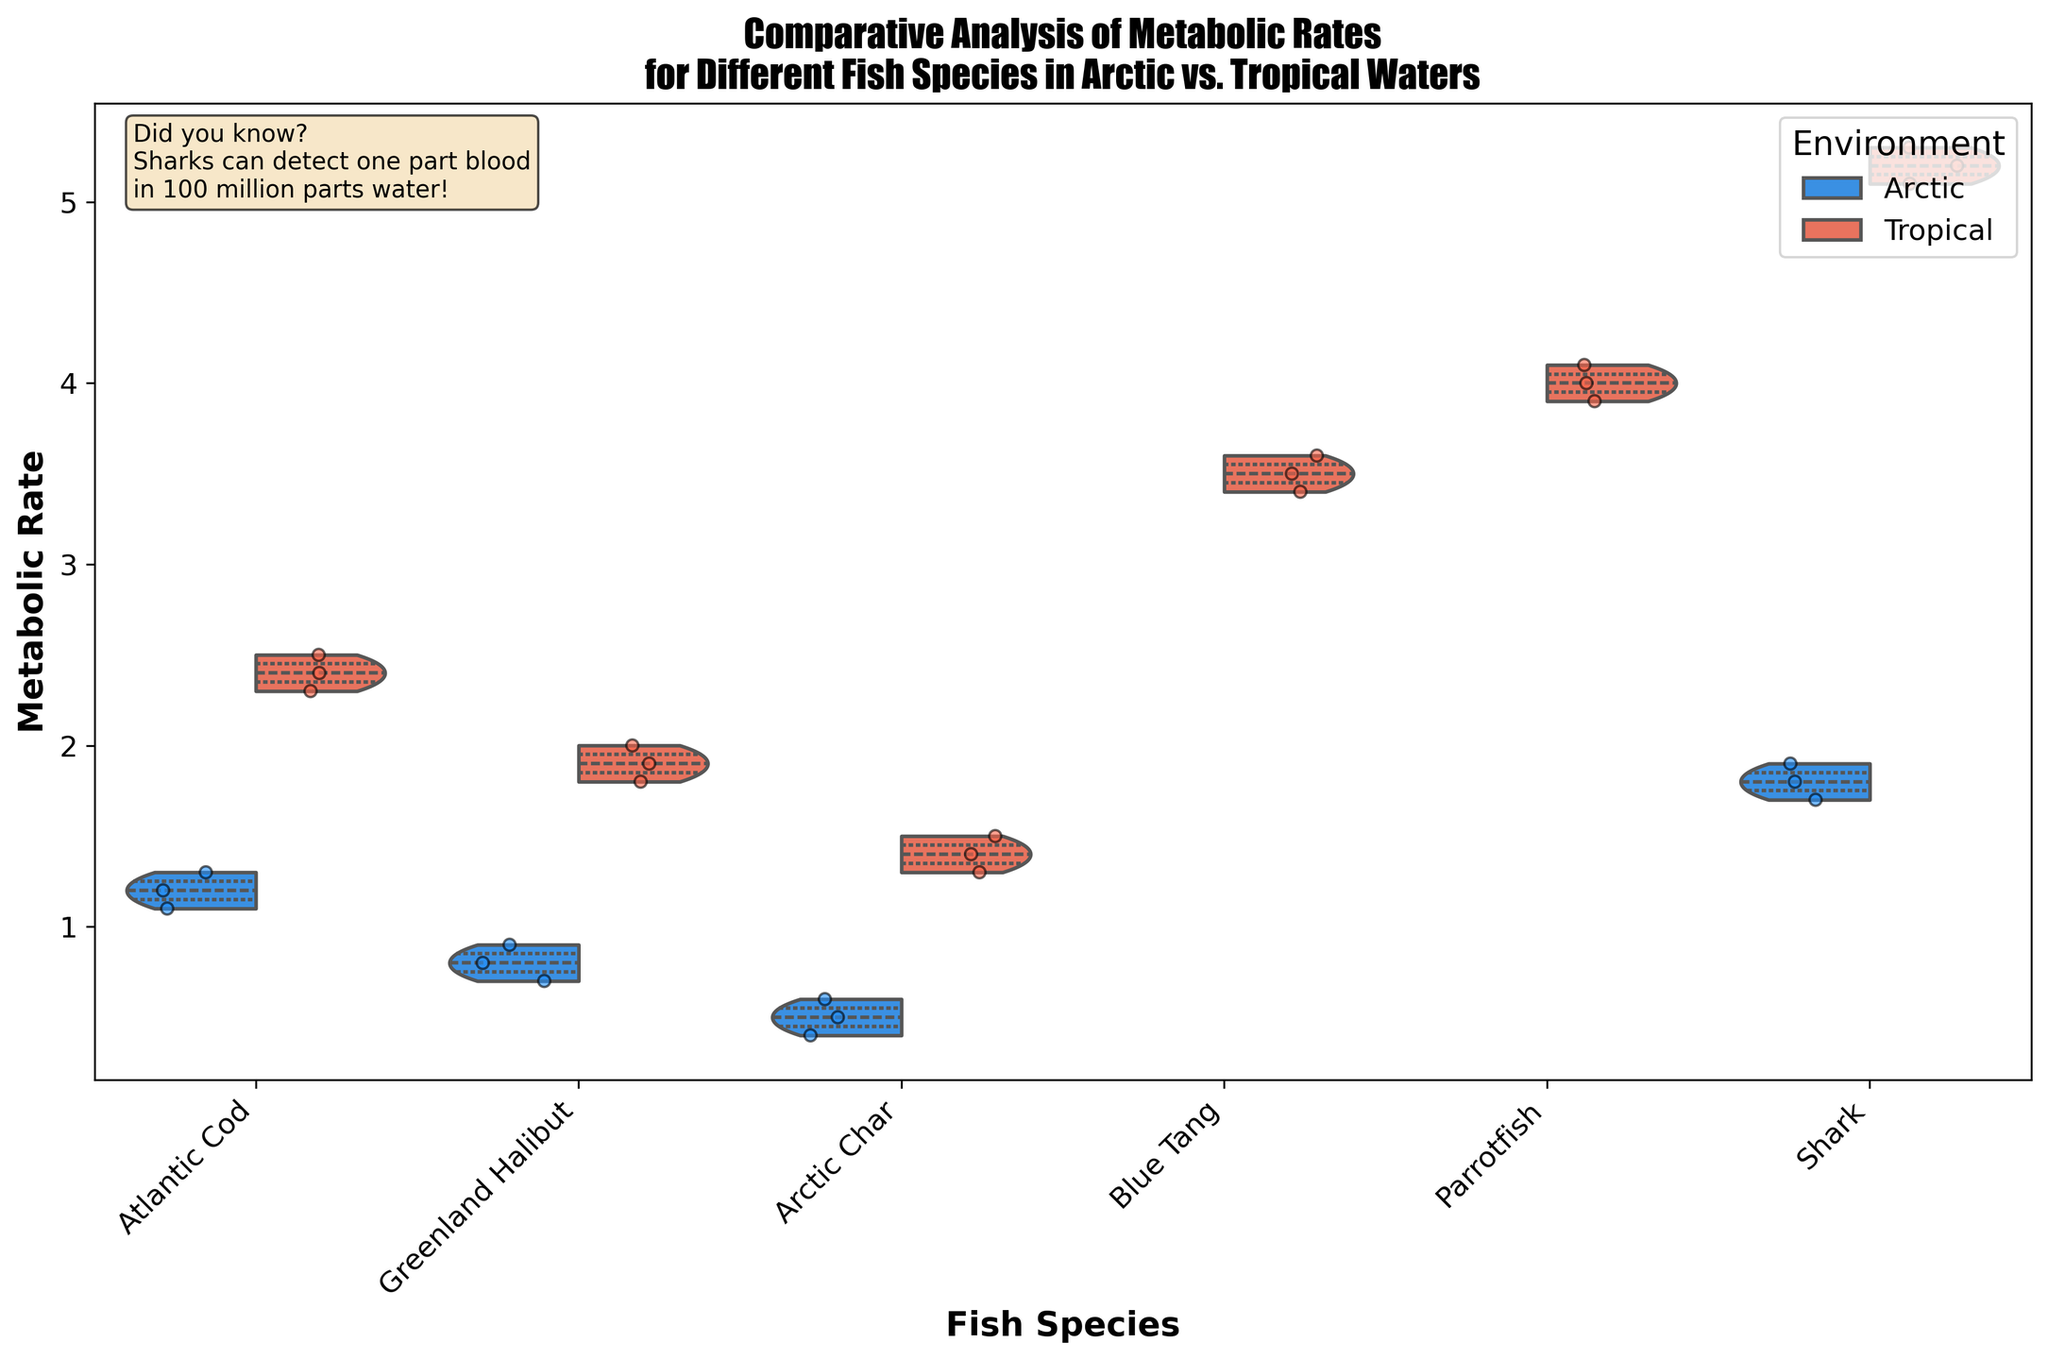What's the title of the figure? The title is printed at the top of the figure, describing what the plot represents.
Answer: Comparative Analysis of Metabolic Rates for Different Fish Species in Arctic vs. Tropical Waters What are the two environments being compared in the figure? The hue (color) differentiation and the legend indicate the two environments being compared. The labels show "Arctic" and "Tropical".
Answer: Arctic, Tropical Which fish species exhibits the highest metabolic rate in tropical waters? The species with the highest point on the y-axis in the Tropical environment is Shark, reaching above 5.0.
Answer: Shark How does the median metabolic rate of Atlantic Cod in Arctic waters compare to that in Tropical waters? The median is represented by the thickest horizontal lines within the violin plots. For Atlantic Cod, the Arctic median is around 1.2 while the Tropical median is around 2.4.
Answer: Tropical median is higher Which environment has a wider range of metabolic rates for Greenland Halibut? Width of the violin plots reflects the distribution range. For Greenland Halibut, the Arctic range is more compressed compared to the wider range in Tropical waters, indicated by a broader violin.
Answer: Tropical On average, how do the metabolic rates of Shark in Arctic waters compare to those in Tropical waters? Averaging can be visually estimated through the position of the central part of the violin. For Sharks, the central violin is higher in Tropical waters (around 5.2) compared to Arctic waters (around 1.8).
Answer: Higher in Tropical How does the variability of metabolic rates in Arctic Char compare between the two environments? The variability is indicated by the spread of the violin and the positions of jittered points. Arctic Char shows a narrower spread in Arctic waters compared to the wider and slightly higher spread in Tropical waters.
Answer: Higher in Tropical Which fish species has the smallest difference in metabolic rates between the Arctic and Tropical environments? By comparing the overlap of the violin plots for each species between the two environments, Arctic Char has the smallest difference (Arctic around 0.5 and Tropical around 1.4).
Answer: Arctic Char What's the range of metabolic rates for Blue Tang in Tropical waters? The range is the span from the bottom to the top of the violin plot for Blue Tang, ranging approximately from 3.4 to 3.6.
Answer: 3.4 to 3.6 How many species are displayed in the figure? The x-axis labels indicate distinct species being plotted. The plot shows 6 distinct fish species.
Answer: 6 